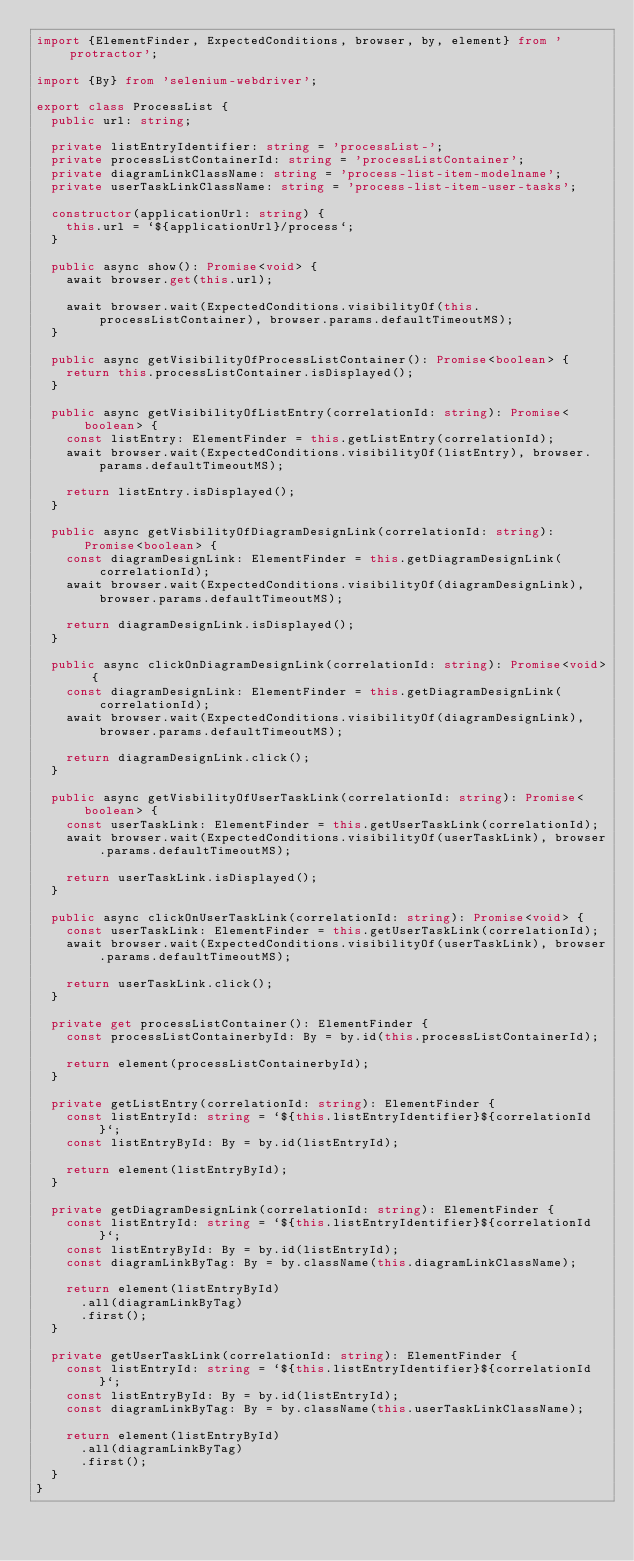Convert code to text. <code><loc_0><loc_0><loc_500><loc_500><_TypeScript_>import {ElementFinder, ExpectedConditions, browser, by, element} from 'protractor';

import {By} from 'selenium-webdriver';

export class ProcessList {
  public url: string;

  private listEntryIdentifier: string = 'processList-';
  private processListContainerId: string = 'processListContainer';
  private diagramLinkClassName: string = 'process-list-item-modelname';
  private userTaskLinkClassName: string = 'process-list-item-user-tasks';

  constructor(applicationUrl: string) {
    this.url = `${applicationUrl}/process`;
  }

  public async show(): Promise<void> {
    await browser.get(this.url);

    await browser.wait(ExpectedConditions.visibilityOf(this.processListContainer), browser.params.defaultTimeoutMS);
  }

  public async getVisibilityOfProcessListContainer(): Promise<boolean> {
    return this.processListContainer.isDisplayed();
  }

  public async getVisibilityOfListEntry(correlationId: string): Promise<boolean> {
    const listEntry: ElementFinder = this.getListEntry(correlationId);
    await browser.wait(ExpectedConditions.visibilityOf(listEntry), browser.params.defaultTimeoutMS);

    return listEntry.isDisplayed();
  }

  public async getVisbilityOfDiagramDesignLink(correlationId: string): Promise<boolean> {
    const diagramDesignLink: ElementFinder = this.getDiagramDesignLink(correlationId);
    await browser.wait(ExpectedConditions.visibilityOf(diagramDesignLink), browser.params.defaultTimeoutMS);

    return diagramDesignLink.isDisplayed();
  }

  public async clickOnDiagramDesignLink(correlationId: string): Promise<void> {
    const diagramDesignLink: ElementFinder = this.getDiagramDesignLink(correlationId);
    await browser.wait(ExpectedConditions.visibilityOf(diagramDesignLink), browser.params.defaultTimeoutMS);

    return diagramDesignLink.click();
  }

  public async getVisbilityOfUserTaskLink(correlationId: string): Promise<boolean> {
    const userTaskLink: ElementFinder = this.getUserTaskLink(correlationId);
    await browser.wait(ExpectedConditions.visibilityOf(userTaskLink), browser.params.defaultTimeoutMS);

    return userTaskLink.isDisplayed();
  }

  public async clickOnUserTaskLink(correlationId: string): Promise<void> {
    const userTaskLink: ElementFinder = this.getUserTaskLink(correlationId);
    await browser.wait(ExpectedConditions.visibilityOf(userTaskLink), browser.params.defaultTimeoutMS);

    return userTaskLink.click();
  }

  private get processListContainer(): ElementFinder {
    const processListContainerbyId: By = by.id(this.processListContainerId);

    return element(processListContainerbyId);
  }

  private getListEntry(correlationId: string): ElementFinder {
    const listEntryId: string = `${this.listEntryIdentifier}${correlationId}`;
    const listEntryById: By = by.id(listEntryId);

    return element(listEntryById);
  }

  private getDiagramDesignLink(correlationId: string): ElementFinder {
    const listEntryId: string = `${this.listEntryIdentifier}${correlationId}`;
    const listEntryById: By = by.id(listEntryId);
    const diagramLinkByTag: By = by.className(this.diagramLinkClassName);

    return element(listEntryById)
      .all(diagramLinkByTag)
      .first();
  }

  private getUserTaskLink(correlationId: string): ElementFinder {
    const listEntryId: string = `${this.listEntryIdentifier}${correlationId}`;
    const listEntryById: By = by.id(listEntryId);
    const diagramLinkByTag: By = by.className(this.userTaskLinkClassName);

    return element(listEntryById)
      .all(diagramLinkByTag)
      .first();
  }
}
</code> 